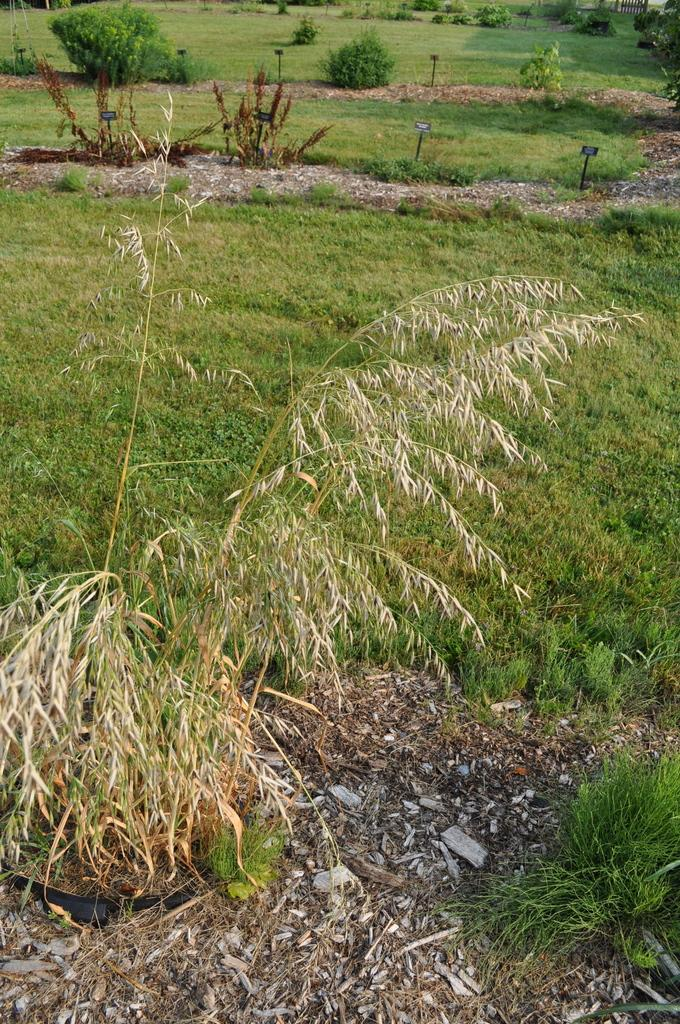What type of vegetation is present in the image? There is grass and plants in the image. What else can be seen in the image besides vegetation? There are boards in the image. What type of news is being reported by the writer in the image? There is no writer or news present in the image; it only features grass, plants, and boards. 